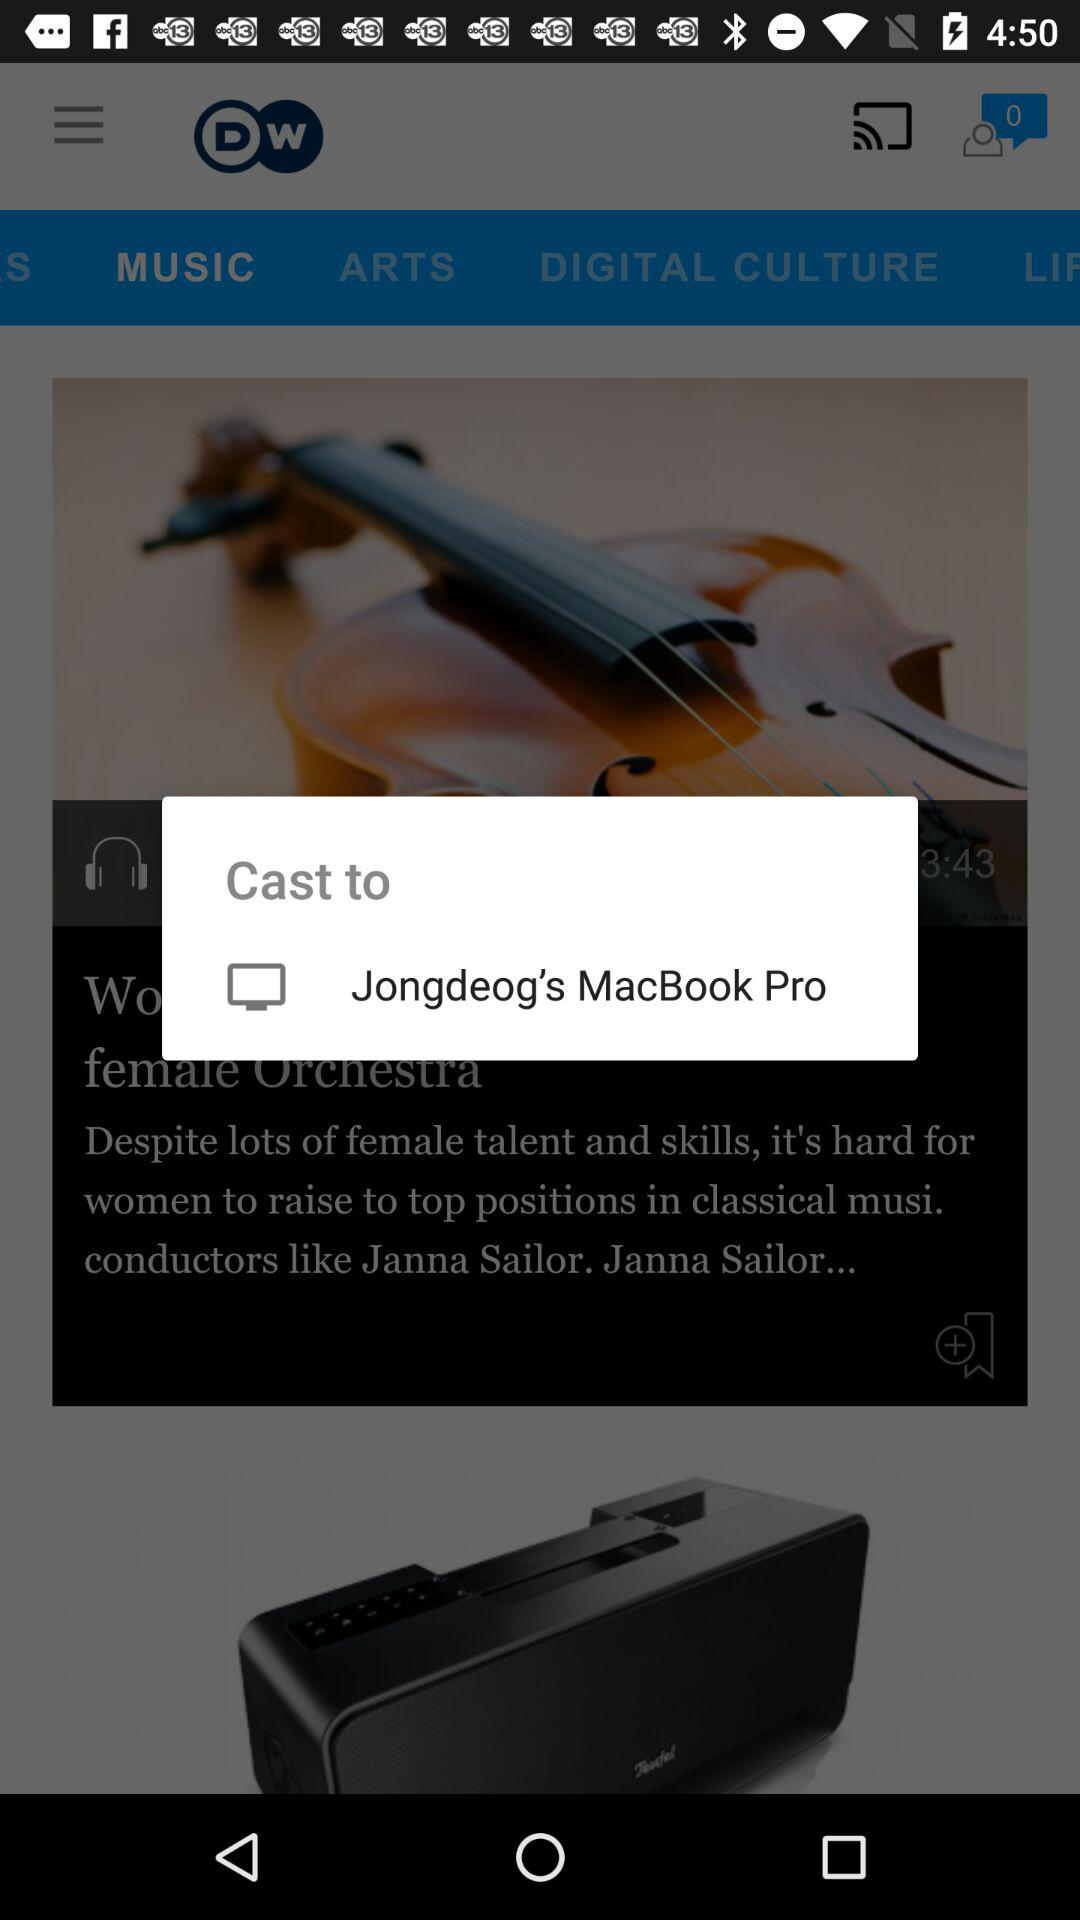What is the selected language? The selected language is English. 